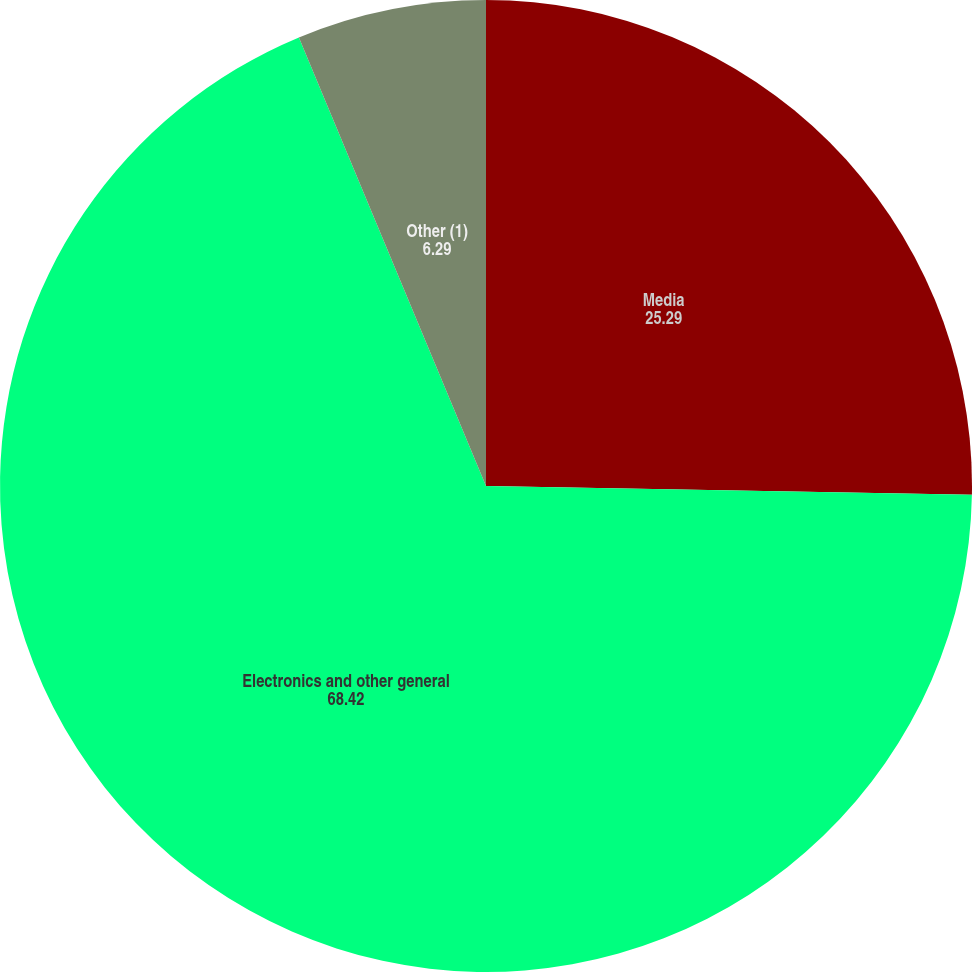Convert chart. <chart><loc_0><loc_0><loc_500><loc_500><pie_chart><fcel>Media<fcel>Electronics and other general<fcel>Other (1)<nl><fcel>25.29%<fcel>68.42%<fcel>6.29%<nl></chart> 